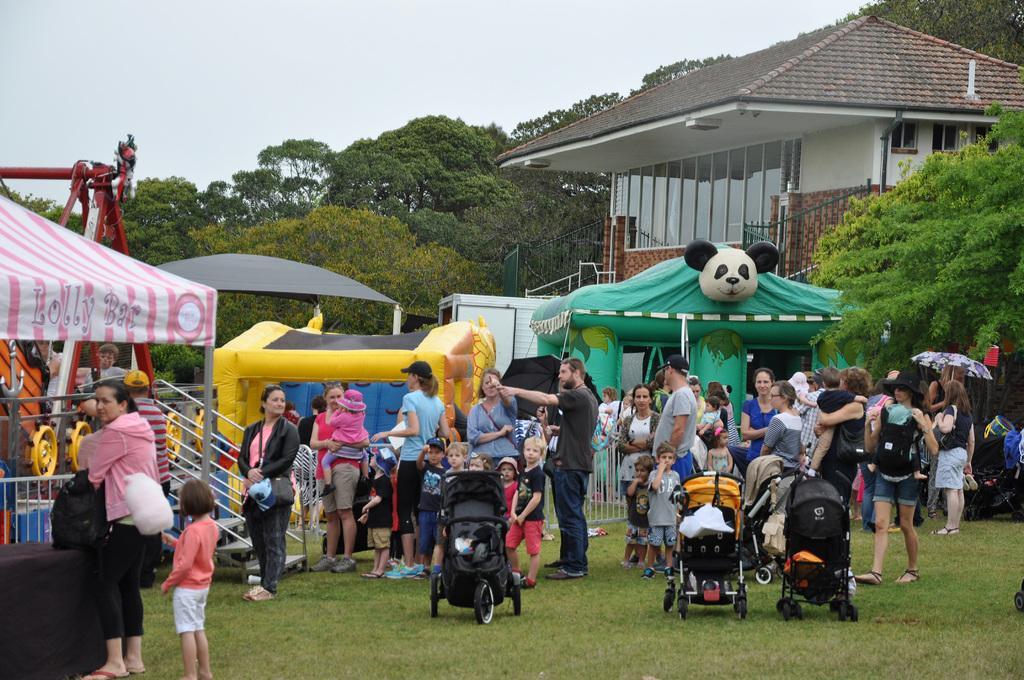Describe this image in one or two sentences. In this image in the center there are a group of people who are standing and there are some stores and tents and some toys. And also there are some wheelchairs, in the background there are some trees, houses. At the bottom there is grass, at the top of the image there is sky. 